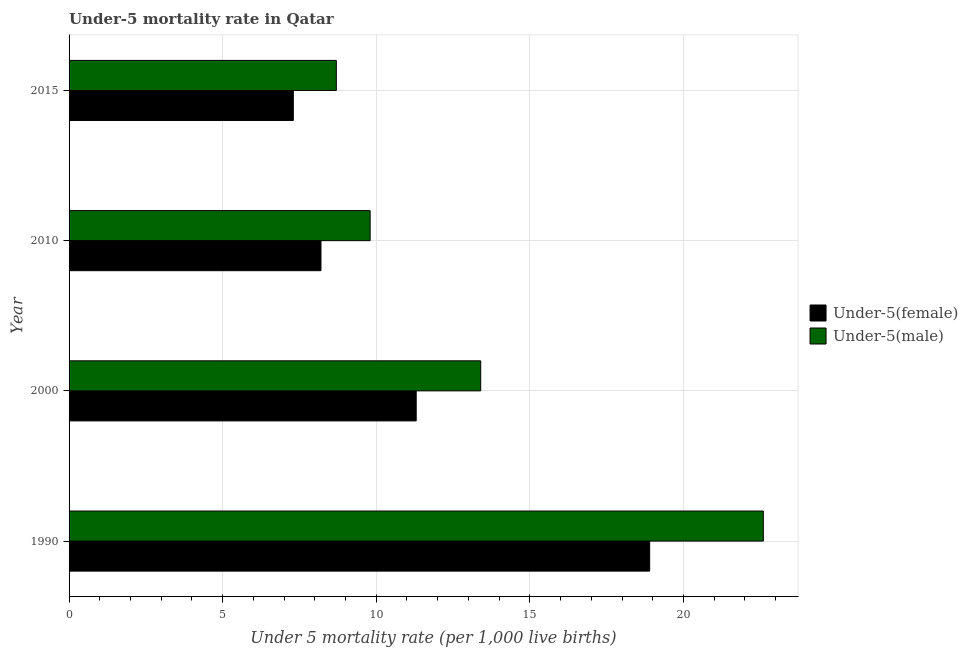How many different coloured bars are there?
Give a very brief answer. 2. How many groups of bars are there?
Your answer should be compact. 4. How many bars are there on the 2nd tick from the top?
Keep it short and to the point. 2. What is the label of the 2nd group of bars from the top?
Offer a very short reply. 2010. In how many cases, is the number of bars for a given year not equal to the number of legend labels?
Keep it short and to the point. 0. Across all years, what is the maximum under-5 male mortality rate?
Keep it short and to the point. 22.6. In which year was the under-5 male mortality rate maximum?
Offer a terse response. 1990. In which year was the under-5 female mortality rate minimum?
Make the answer very short. 2015. What is the total under-5 male mortality rate in the graph?
Your response must be concise. 54.5. What is the average under-5 female mortality rate per year?
Make the answer very short. 11.43. In the year 2000, what is the difference between the under-5 female mortality rate and under-5 male mortality rate?
Your answer should be very brief. -2.1. What is the ratio of the under-5 female mortality rate in 1990 to that in 2015?
Your answer should be compact. 2.59. In how many years, is the under-5 male mortality rate greater than the average under-5 male mortality rate taken over all years?
Make the answer very short. 1. Is the sum of the under-5 female mortality rate in 1990 and 2010 greater than the maximum under-5 male mortality rate across all years?
Your answer should be very brief. Yes. What does the 1st bar from the top in 1990 represents?
Offer a terse response. Under-5(male). What does the 2nd bar from the bottom in 2015 represents?
Your answer should be compact. Under-5(male). How many bars are there?
Provide a succinct answer. 8. Does the graph contain any zero values?
Provide a succinct answer. No. How many legend labels are there?
Your answer should be compact. 2. What is the title of the graph?
Give a very brief answer. Under-5 mortality rate in Qatar. What is the label or title of the X-axis?
Keep it short and to the point. Under 5 mortality rate (per 1,0 live births). What is the label or title of the Y-axis?
Your answer should be compact. Year. What is the Under 5 mortality rate (per 1,000 live births) of Under-5(female) in 1990?
Ensure brevity in your answer.  18.9. What is the Under 5 mortality rate (per 1,000 live births) in Under-5(male) in 1990?
Your answer should be compact. 22.6. What is the Under 5 mortality rate (per 1,000 live births) of Under-5(male) in 2010?
Your answer should be very brief. 9.8. Across all years, what is the maximum Under 5 mortality rate (per 1,000 live births) in Under-5(male)?
Offer a terse response. 22.6. What is the total Under 5 mortality rate (per 1,000 live births) in Under-5(female) in the graph?
Your answer should be compact. 45.7. What is the total Under 5 mortality rate (per 1,000 live births) in Under-5(male) in the graph?
Your response must be concise. 54.5. What is the difference between the Under 5 mortality rate (per 1,000 live births) of Under-5(female) in 1990 and that in 2000?
Provide a short and direct response. 7.6. What is the difference between the Under 5 mortality rate (per 1,000 live births) of Under-5(female) in 1990 and that in 2010?
Provide a succinct answer. 10.7. What is the difference between the Under 5 mortality rate (per 1,000 live births) in Under-5(male) in 1990 and that in 2010?
Offer a very short reply. 12.8. What is the difference between the Under 5 mortality rate (per 1,000 live births) of Under-5(female) in 1990 and that in 2015?
Your answer should be very brief. 11.6. What is the difference between the Under 5 mortality rate (per 1,000 live births) in Under-5(female) in 2000 and that in 2015?
Offer a terse response. 4. What is the difference between the Under 5 mortality rate (per 1,000 live births) of Under-5(female) in 2010 and that in 2015?
Ensure brevity in your answer.  0.9. What is the difference between the Under 5 mortality rate (per 1,000 live births) in Under-5(male) in 2010 and that in 2015?
Keep it short and to the point. 1.1. What is the difference between the Under 5 mortality rate (per 1,000 live births) of Under-5(female) in 1990 and the Under 5 mortality rate (per 1,000 live births) of Under-5(male) in 2000?
Give a very brief answer. 5.5. What is the difference between the Under 5 mortality rate (per 1,000 live births) of Under-5(female) in 1990 and the Under 5 mortality rate (per 1,000 live births) of Under-5(male) in 2010?
Offer a very short reply. 9.1. What is the difference between the Under 5 mortality rate (per 1,000 live births) in Under-5(female) in 2000 and the Under 5 mortality rate (per 1,000 live births) in Under-5(male) in 2010?
Provide a succinct answer. 1.5. What is the difference between the Under 5 mortality rate (per 1,000 live births) in Under-5(female) in 2010 and the Under 5 mortality rate (per 1,000 live births) in Under-5(male) in 2015?
Keep it short and to the point. -0.5. What is the average Under 5 mortality rate (per 1,000 live births) of Under-5(female) per year?
Your response must be concise. 11.43. What is the average Under 5 mortality rate (per 1,000 live births) in Under-5(male) per year?
Keep it short and to the point. 13.62. In the year 1990, what is the difference between the Under 5 mortality rate (per 1,000 live births) in Under-5(female) and Under 5 mortality rate (per 1,000 live births) in Under-5(male)?
Your answer should be very brief. -3.7. In the year 2000, what is the difference between the Under 5 mortality rate (per 1,000 live births) in Under-5(female) and Under 5 mortality rate (per 1,000 live births) in Under-5(male)?
Keep it short and to the point. -2.1. What is the ratio of the Under 5 mortality rate (per 1,000 live births) in Under-5(female) in 1990 to that in 2000?
Offer a very short reply. 1.67. What is the ratio of the Under 5 mortality rate (per 1,000 live births) of Under-5(male) in 1990 to that in 2000?
Keep it short and to the point. 1.69. What is the ratio of the Under 5 mortality rate (per 1,000 live births) in Under-5(female) in 1990 to that in 2010?
Your response must be concise. 2.3. What is the ratio of the Under 5 mortality rate (per 1,000 live births) of Under-5(male) in 1990 to that in 2010?
Provide a succinct answer. 2.31. What is the ratio of the Under 5 mortality rate (per 1,000 live births) of Under-5(female) in 1990 to that in 2015?
Offer a terse response. 2.59. What is the ratio of the Under 5 mortality rate (per 1,000 live births) of Under-5(male) in 1990 to that in 2015?
Your answer should be very brief. 2.6. What is the ratio of the Under 5 mortality rate (per 1,000 live births) in Under-5(female) in 2000 to that in 2010?
Your answer should be very brief. 1.38. What is the ratio of the Under 5 mortality rate (per 1,000 live births) in Under-5(male) in 2000 to that in 2010?
Offer a very short reply. 1.37. What is the ratio of the Under 5 mortality rate (per 1,000 live births) in Under-5(female) in 2000 to that in 2015?
Give a very brief answer. 1.55. What is the ratio of the Under 5 mortality rate (per 1,000 live births) in Under-5(male) in 2000 to that in 2015?
Provide a short and direct response. 1.54. What is the ratio of the Under 5 mortality rate (per 1,000 live births) of Under-5(female) in 2010 to that in 2015?
Your response must be concise. 1.12. What is the ratio of the Under 5 mortality rate (per 1,000 live births) in Under-5(male) in 2010 to that in 2015?
Ensure brevity in your answer.  1.13. What is the difference between the highest and the lowest Under 5 mortality rate (per 1,000 live births) of Under-5(female)?
Ensure brevity in your answer.  11.6. 